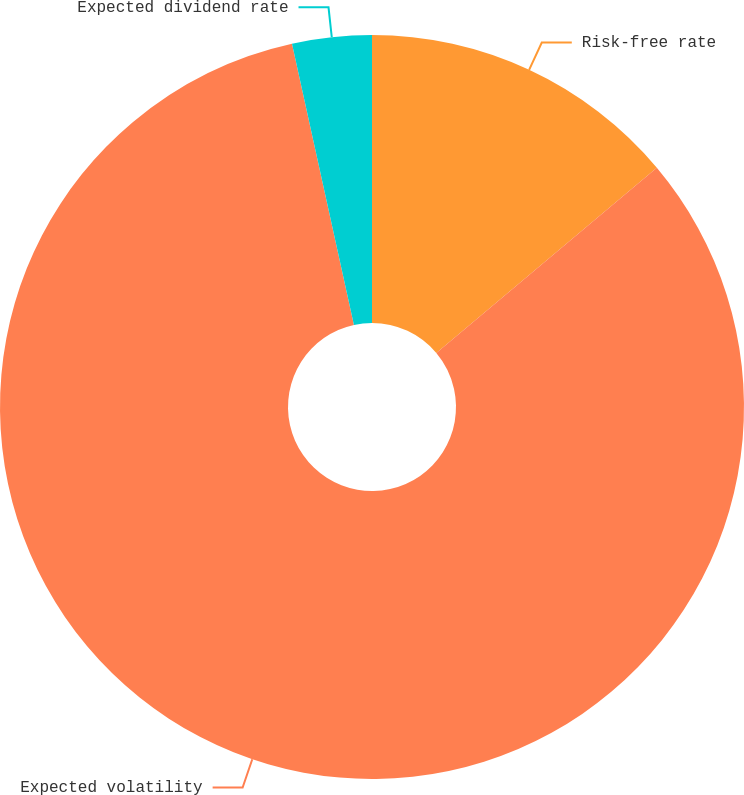Convert chart to OTSL. <chart><loc_0><loc_0><loc_500><loc_500><pie_chart><fcel>Risk-free rate<fcel>Expected volatility<fcel>Expected dividend rate<nl><fcel>13.88%<fcel>82.67%<fcel>3.45%<nl></chart> 